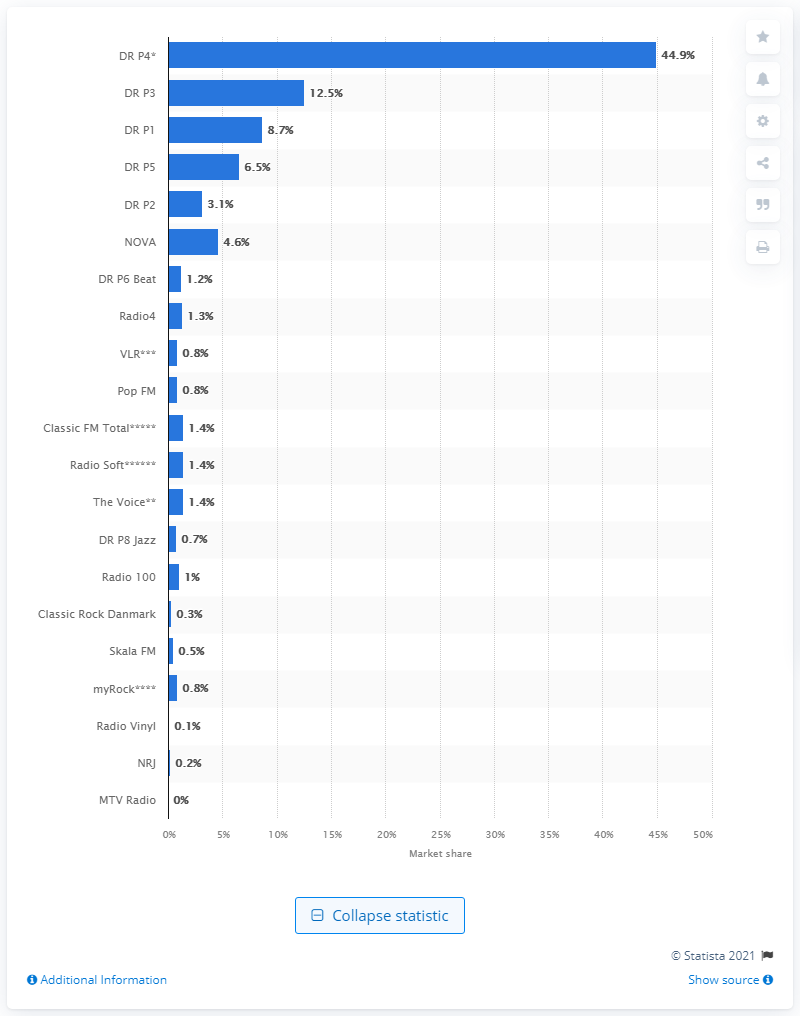Give some essential details in this illustration. The audience share of DR P1 was 8.7.. According to data from June 2021, the market share of Danish Broadcasting Corporation's radio channel was 44.9%. The market share of DR P3 was 12.5%. 